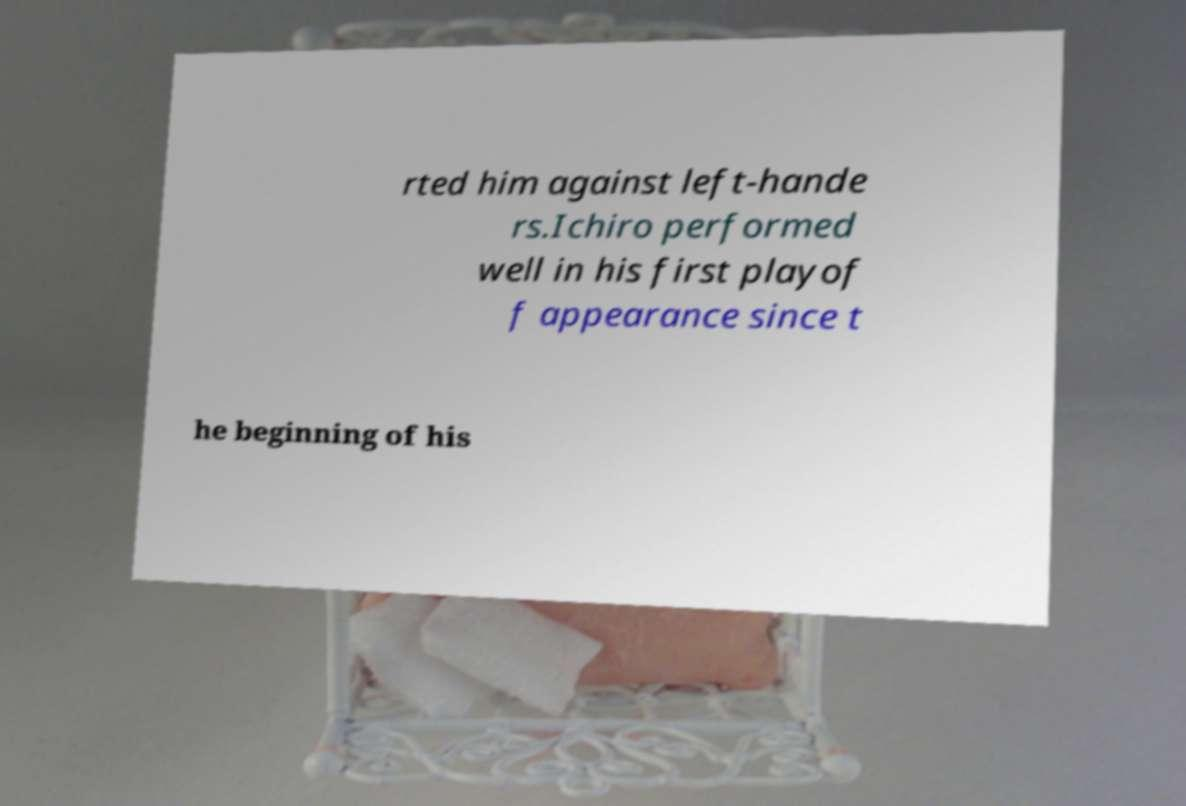Please identify and transcribe the text found in this image. rted him against left-hande rs.Ichiro performed well in his first playof f appearance since t he beginning of his 